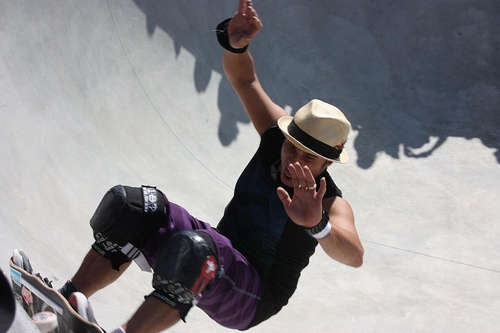Describe the objects in this image and their specific colors. I can see people in darkgray, black, maroon, lightgray, and gray tones and skateboard in darkgray, gray, black, and lightgray tones in this image. 